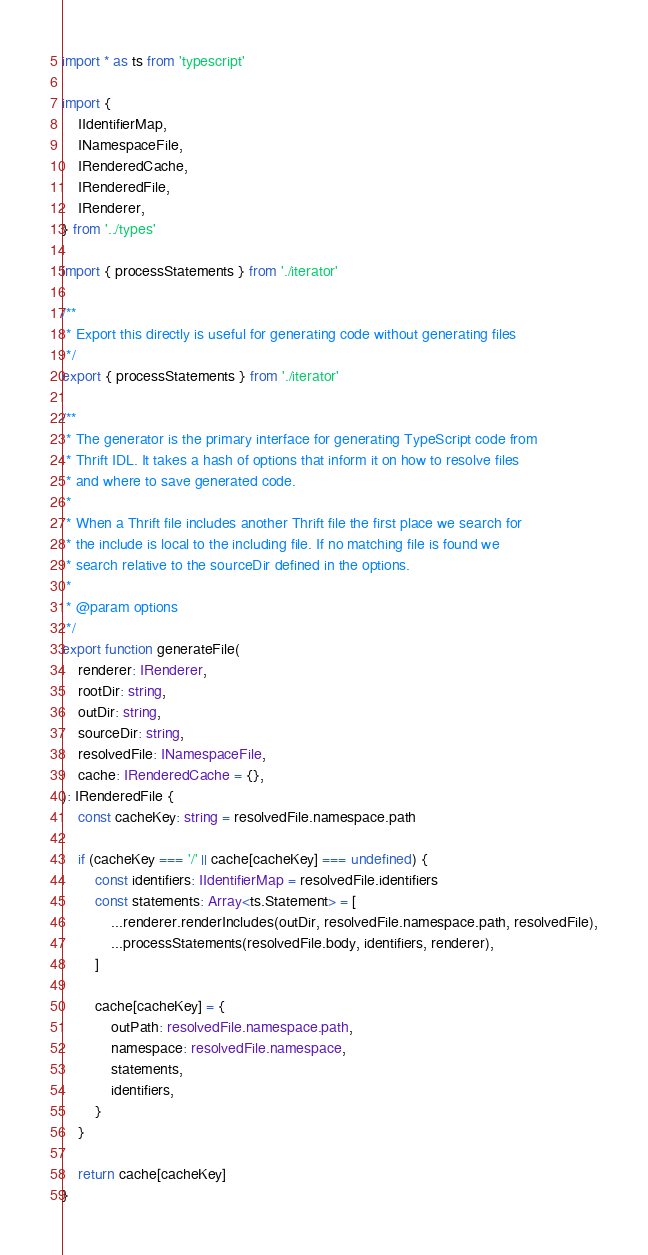<code> <loc_0><loc_0><loc_500><loc_500><_TypeScript_>import * as ts from 'typescript'

import {
    IIdentifierMap,
    INamespaceFile,
    IRenderedCache,
    IRenderedFile,
    IRenderer,
} from '../types'

import { processStatements } from './iterator'

/**
 * Export this directly is useful for generating code without generating files
 */
export { processStatements } from './iterator'

/**
 * The generator is the primary interface for generating TypeScript code from
 * Thrift IDL. It takes a hash of options that inform it on how to resolve files
 * and where to save generated code.
 *
 * When a Thrift file includes another Thrift file the first place we search for
 * the include is local to the including file. If no matching file is found we
 * search relative to the sourceDir defined in the options.
 *
 * @param options
 */
export function generateFile(
    renderer: IRenderer,
    rootDir: string,
    outDir: string,
    sourceDir: string,
    resolvedFile: INamespaceFile,
    cache: IRenderedCache = {},
): IRenderedFile {
    const cacheKey: string = resolvedFile.namespace.path

    if (cacheKey === '/' || cache[cacheKey] === undefined) {
        const identifiers: IIdentifierMap = resolvedFile.identifiers
        const statements: Array<ts.Statement> = [
            ...renderer.renderIncludes(outDir, resolvedFile.namespace.path, resolvedFile),
            ...processStatements(resolvedFile.body, identifiers, renderer),
        ]

        cache[cacheKey] = {
            outPath: resolvedFile.namespace.path,
            namespace: resolvedFile.namespace,
            statements,
            identifiers,
        }
    }

    return cache[cacheKey]
}
</code> 